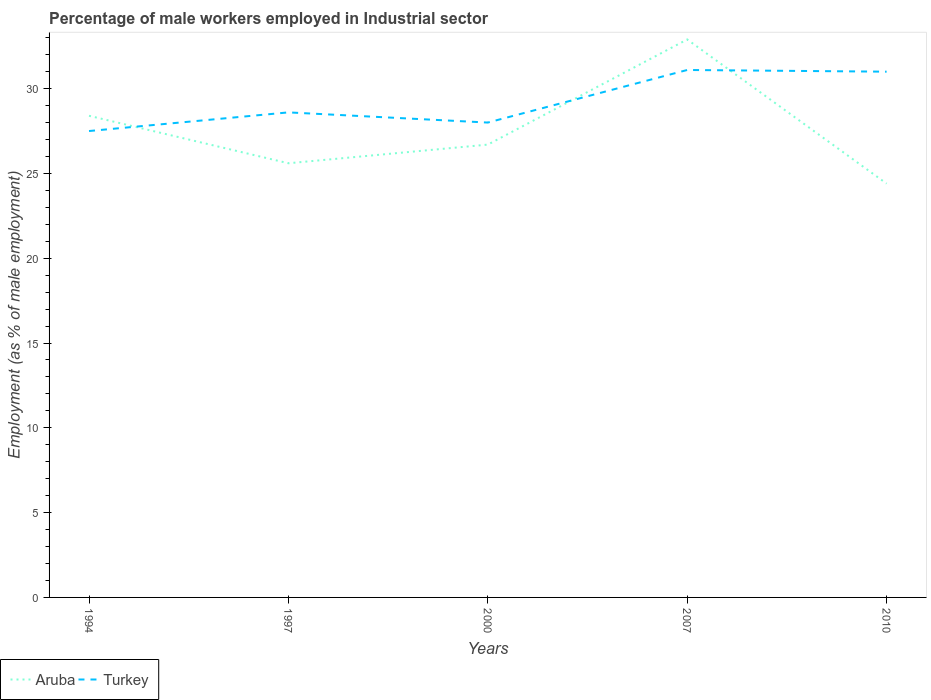Does the line corresponding to Turkey intersect with the line corresponding to Aruba?
Offer a very short reply. Yes. What is the total percentage of male workers employed in Industrial sector in Turkey in the graph?
Give a very brief answer. -3.5. What is the difference between the highest and the second highest percentage of male workers employed in Industrial sector in Turkey?
Give a very brief answer. 3.6. Is the percentage of male workers employed in Industrial sector in Aruba strictly greater than the percentage of male workers employed in Industrial sector in Turkey over the years?
Offer a terse response. No. Are the values on the major ticks of Y-axis written in scientific E-notation?
Your answer should be very brief. No. Does the graph contain any zero values?
Your answer should be compact. No. How are the legend labels stacked?
Your answer should be very brief. Horizontal. What is the title of the graph?
Your response must be concise. Percentage of male workers employed in Industrial sector. What is the label or title of the Y-axis?
Your answer should be very brief. Employment (as % of male employment). What is the Employment (as % of male employment) of Aruba in 1994?
Your answer should be very brief. 28.4. What is the Employment (as % of male employment) in Turkey in 1994?
Offer a terse response. 27.5. What is the Employment (as % of male employment) of Aruba in 1997?
Give a very brief answer. 25.6. What is the Employment (as % of male employment) of Turkey in 1997?
Your answer should be very brief. 28.6. What is the Employment (as % of male employment) in Aruba in 2000?
Ensure brevity in your answer.  26.7. What is the Employment (as % of male employment) of Aruba in 2007?
Provide a short and direct response. 32.9. What is the Employment (as % of male employment) in Turkey in 2007?
Give a very brief answer. 31.1. What is the Employment (as % of male employment) in Aruba in 2010?
Offer a terse response. 24.4. Across all years, what is the maximum Employment (as % of male employment) in Aruba?
Provide a succinct answer. 32.9. Across all years, what is the maximum Employment (as % of male employment) in Turkey?
Your answer should be compact. 31.1. Across all years, what is the minimum Employment (as % of male employment) in Aruba?
Keep it short and to the point. 24.4. Across all years, what is the minimum Employment (as % of male employment) in Turkey?
Provide a short and direct response. 27.5. What is the total Employment (as % of male employment) in Aruba in the graph?
Your answer should be very brief. 138. What is the total Employment (as % of male employment) of Turkey in the graph?
Give a very brief answer. 146.2. What is the difference between the Employment (as % of male employment) in Turkey in 1994 and that in 1997?
Your answer should be compact. -1.1. What is the difference between the Employment (as % of male employment) in Turkey in 1994 and that in 2000?
Make the answer very short. -0.5. What is the difference between the Employment (as % of male employment) of Aruba in 1997 and that in 2007?
Offer a terse response. -7.3. What is the difference between the Employment (as % of male employment) in Turkey in 1997 and that in 2007?
Provide a succinct answer. -2.5. What is the difference between the Employment (as % of male employment) in Aruba in 2000 and that in 2007?
Provide a succinct answer. -6.2. What is the difference between the Employment (as % of male employment) of Aruba in 2000 and that in 2010?
Offer a very short reply. 2.3. What is the difference between the Employment (as % of male employment) in Turkey in 2000 and that in 2010?
Provide a short and direct response. -3. What is the difference between the Employment (as % of male employment) in Aruba in 2007 and that in 2010?
Offer a very short reply. 8.5. What is the difference between the Employment (as % of male employment) of Aruba in 1994 and the Employment (as % of male employment) of Turkey in 2007?
Provide a succinct answer. -2.7. What is the difference between the Employment (as % of male employment) of Aruba in 1997 and the Employment (as % of male employment) of Turkey in 2000?
Offer a very short reply. -2.4. What is the difference between the Employment (as % of male employment) of Aruba in 1997 and the Employment (as % of male employment) of Turkey in 2007?
Keep it short and to the point. -5.5. What is the difference between the Employment (as % of male employment) in Aruba in 1997 and the Employment (as % of male employment) in Turkey in 2010?
Your response must be concise. -5.4. What is the difference between the Employment (as % of male employment) of Aruba in 2000 and the Employment (as % of male employment) of Turkey in 2010?
Provide a succinct answer. -4.3. What is the average Employment (as % of male employment) in Aruba per year?
Provide a short and direct response. 27.6. What is the average Employment (as % of male employment) of Turkey per year?
Your answer should be compact. 29.24. In the year 1994, what is the difference between the Employment (as % of male employment) in Aruba and Employment (as % of male employment) in Turkey?
Your answer should be very brief. 0.9. In the year 1997, what is the difference between the Employment (as % of male employment) in Aruba and Employment (as % of male employment) in Turkey?
Your answer should be very brief. -3. In the year 2007, what is the difference between the Employment (as % of male employment) in Aruba and Employment (as % of male employment) in Turkey?
Your answer should be very brief. 1.8. What is the ratio of the Employment (as % of male employment) in Aruba in 1994 to that in 1997?
Provide a short and direct response. 1.11. What is the ratio of the Employment (as % of male employment) in Turkey in 1994 to that in 1997?
Provide a short and direct response. 0.96. What is the ratio of the Employment (as % of male employment) in Aruba in 1994 to that in 2000?
Provide a short and direct response. 1.06. What is the ratio of the Employment (as % of male employment) of Turkey in 1994 to that in 2000?
Your answer should be very brief. 0.98. What is the ratio of the Employment (as % of male employment) of Aruba in 1994 to that in 2007?
Your answer should be very brief. 0.86. What is the ratio of the Employment (as % of male employment) in Turkey in 1994 to that in 2007?
Keep it short and to the point. 0.88. What is the ratio of the Employment (as % of male employment) of Aruba in 1994 to that in 2010?
Your answer should be very brief. 1.16. What is the ratio of the Employment (as % of male employment) of Turkey in 1994 to that in 2010?
Keep it short and to the point. 0.89. What is the ratio of the Employment (as % of male employment) in Aruba in 1997 to that in 2000?
Make the answer very short. 0.96. What is the ratio of the Employment (as % of male employment) of Turkey in 1997 to that in 2000?
Provide a succinct answer. 1.02. What is the ratio of the Employment (as % of male employment) in Aruba in 1997 to that in 2007?
Offer a very short reply. 0.78. What is the ratio of the Employment (as % of male employment) in Turkey in 1997 to that in 2007?
Your answer should be very brief. 0.92. What is the ratio of the Employment (as % of male employment) in Aruba in 1997 to that in 2010?
Your answer should be compact. 1.05. What is the ratio of the Employment (as % of male employment) in Turkey in 1997 to that in 2010?
Your answer should be compact. 0.92. What is the ratio of the Employment (as % of male employment) of Aruba in 2000 to that in 2007?
Provide a succinct answer. 0.81. What is the ratio of the Employment (as % of male employment) in Turkey in 2000 to that in 2007?
Provide a succinct answer. 0.9. What is the ratio of the Employment (as % of male employment) in Aruba in 2000 to that in 2010?
Make the answer very short. 1.09. What is the ratio of the Employment (as % of male employment) in Turkey in 2000 to that in 2010?
Give a very brief answer. 0.9. What is the ratio of the Employment (as % of male employment) of Aruba in 2007 to that in 2010?
Provide a short and direct response. 1.35. What is the ratio of the Employment (as % of male employment) in Turkey in 2007 to that in 2010?
Give a very brief answer. 1. What is the difference between the highest and the second highest Employment (as % of male employment) in Turkey?
Keep it short and to the point. 0.1. What is the difference between the highest and the lowest Employment (as % of male employment) of Turkey?
Keep it short and to the point. 3.6. 